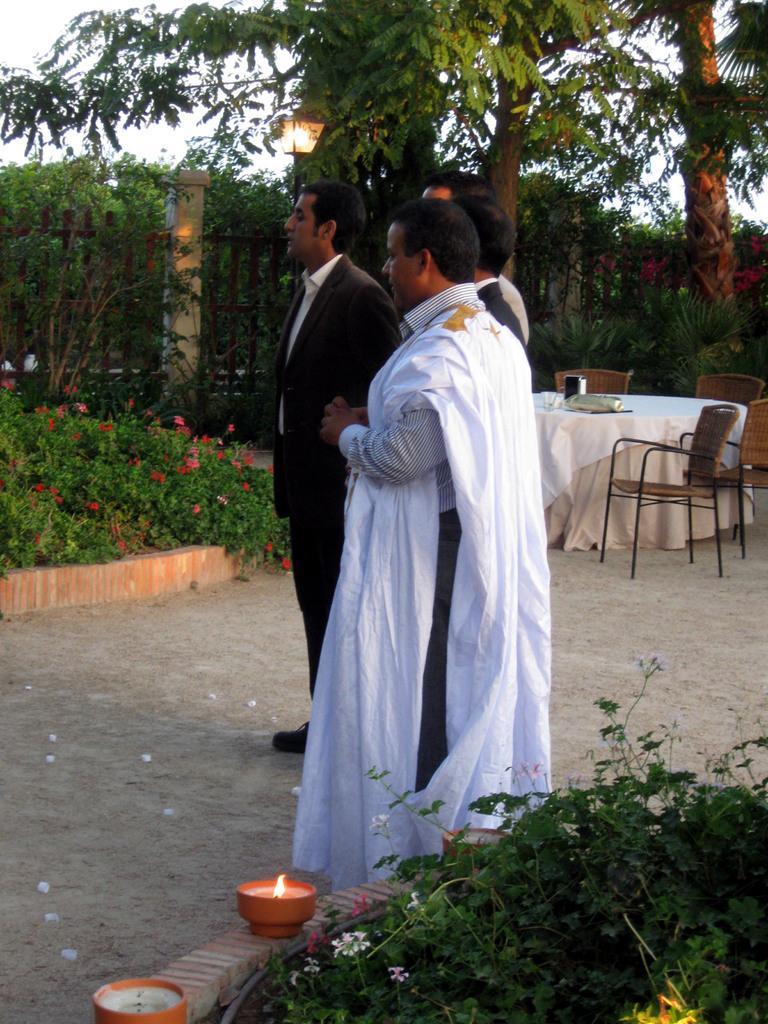Please provide a concise description of this image. There are bushes in the front side of an image there are 3 persons standing in the middle of an image behind them there is a table,chairs behind that there are trees and lights, fire. 